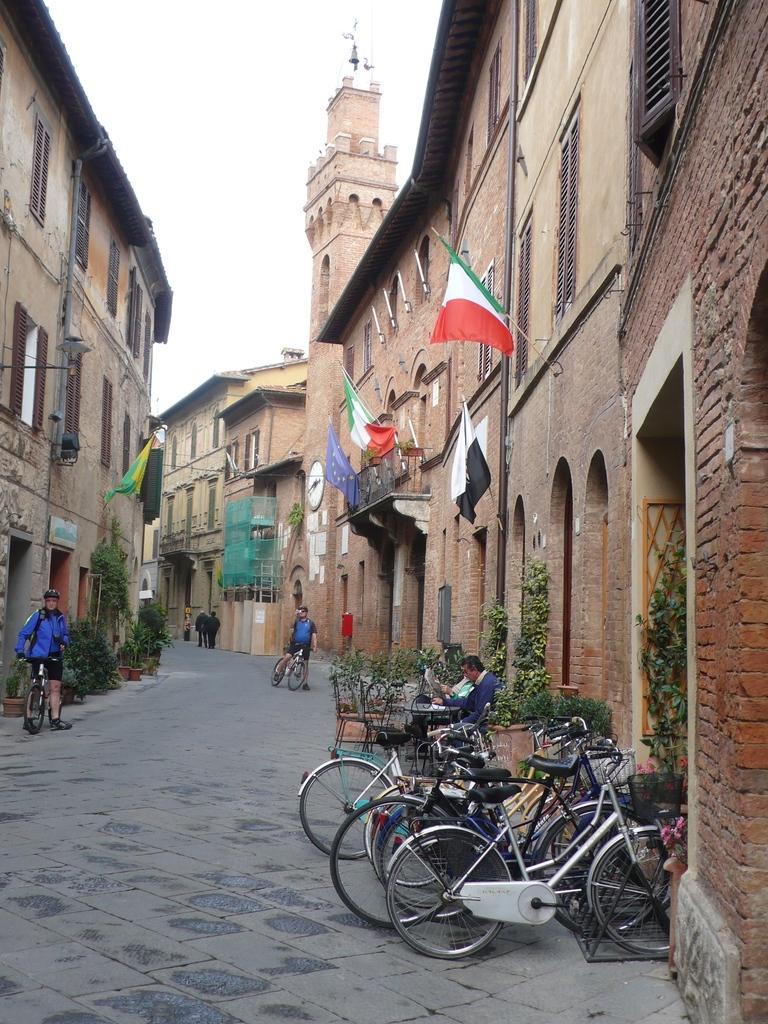Please provide a concise description of this image. In the picture we can see bicycles are parked near the wall, we can see the table, person sitting on the chair, we can see plants, flower pots, these two persons wearing blue color dresses are riding the bicycles on the road, we can see flags, buildings on either side of the image bell and the sky in the background. 